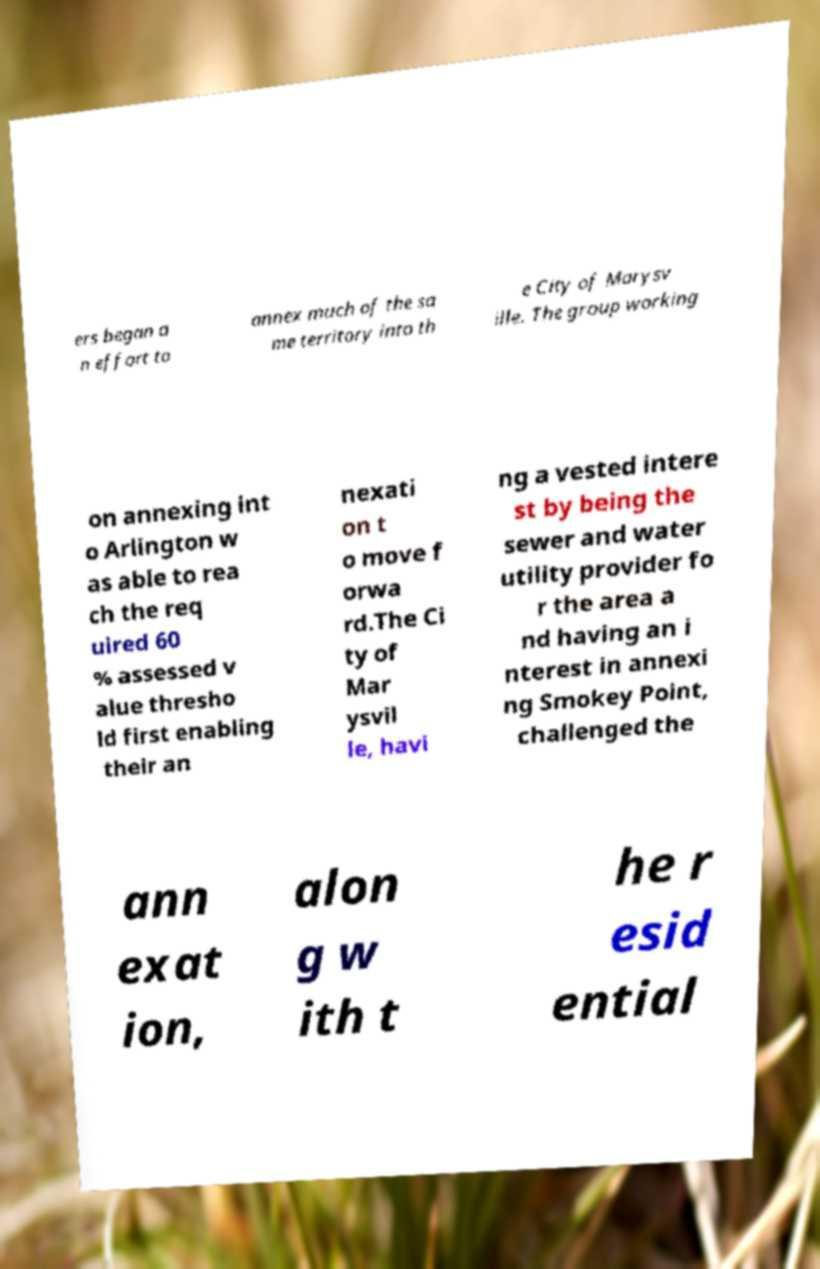Could you assist in decoding the text presented in this image and type it out clearly? ers began a n effort to annex much of the sa me territory into th e City of Marysv ille. The group working on annexing int o Arlington w as able to rea ch the req uired 60 % assessed v alue thresho ld first enabling their an nexati on t o move f orwa rd.The Ci ty of Mar ysvil le, havi ng a vested intere st by being the sewer and water utility provider fo r the area a nd having an i nterest in annexi ng Smokey Point, challenged the ann exat ion, alon g w ith t he r esid ential 